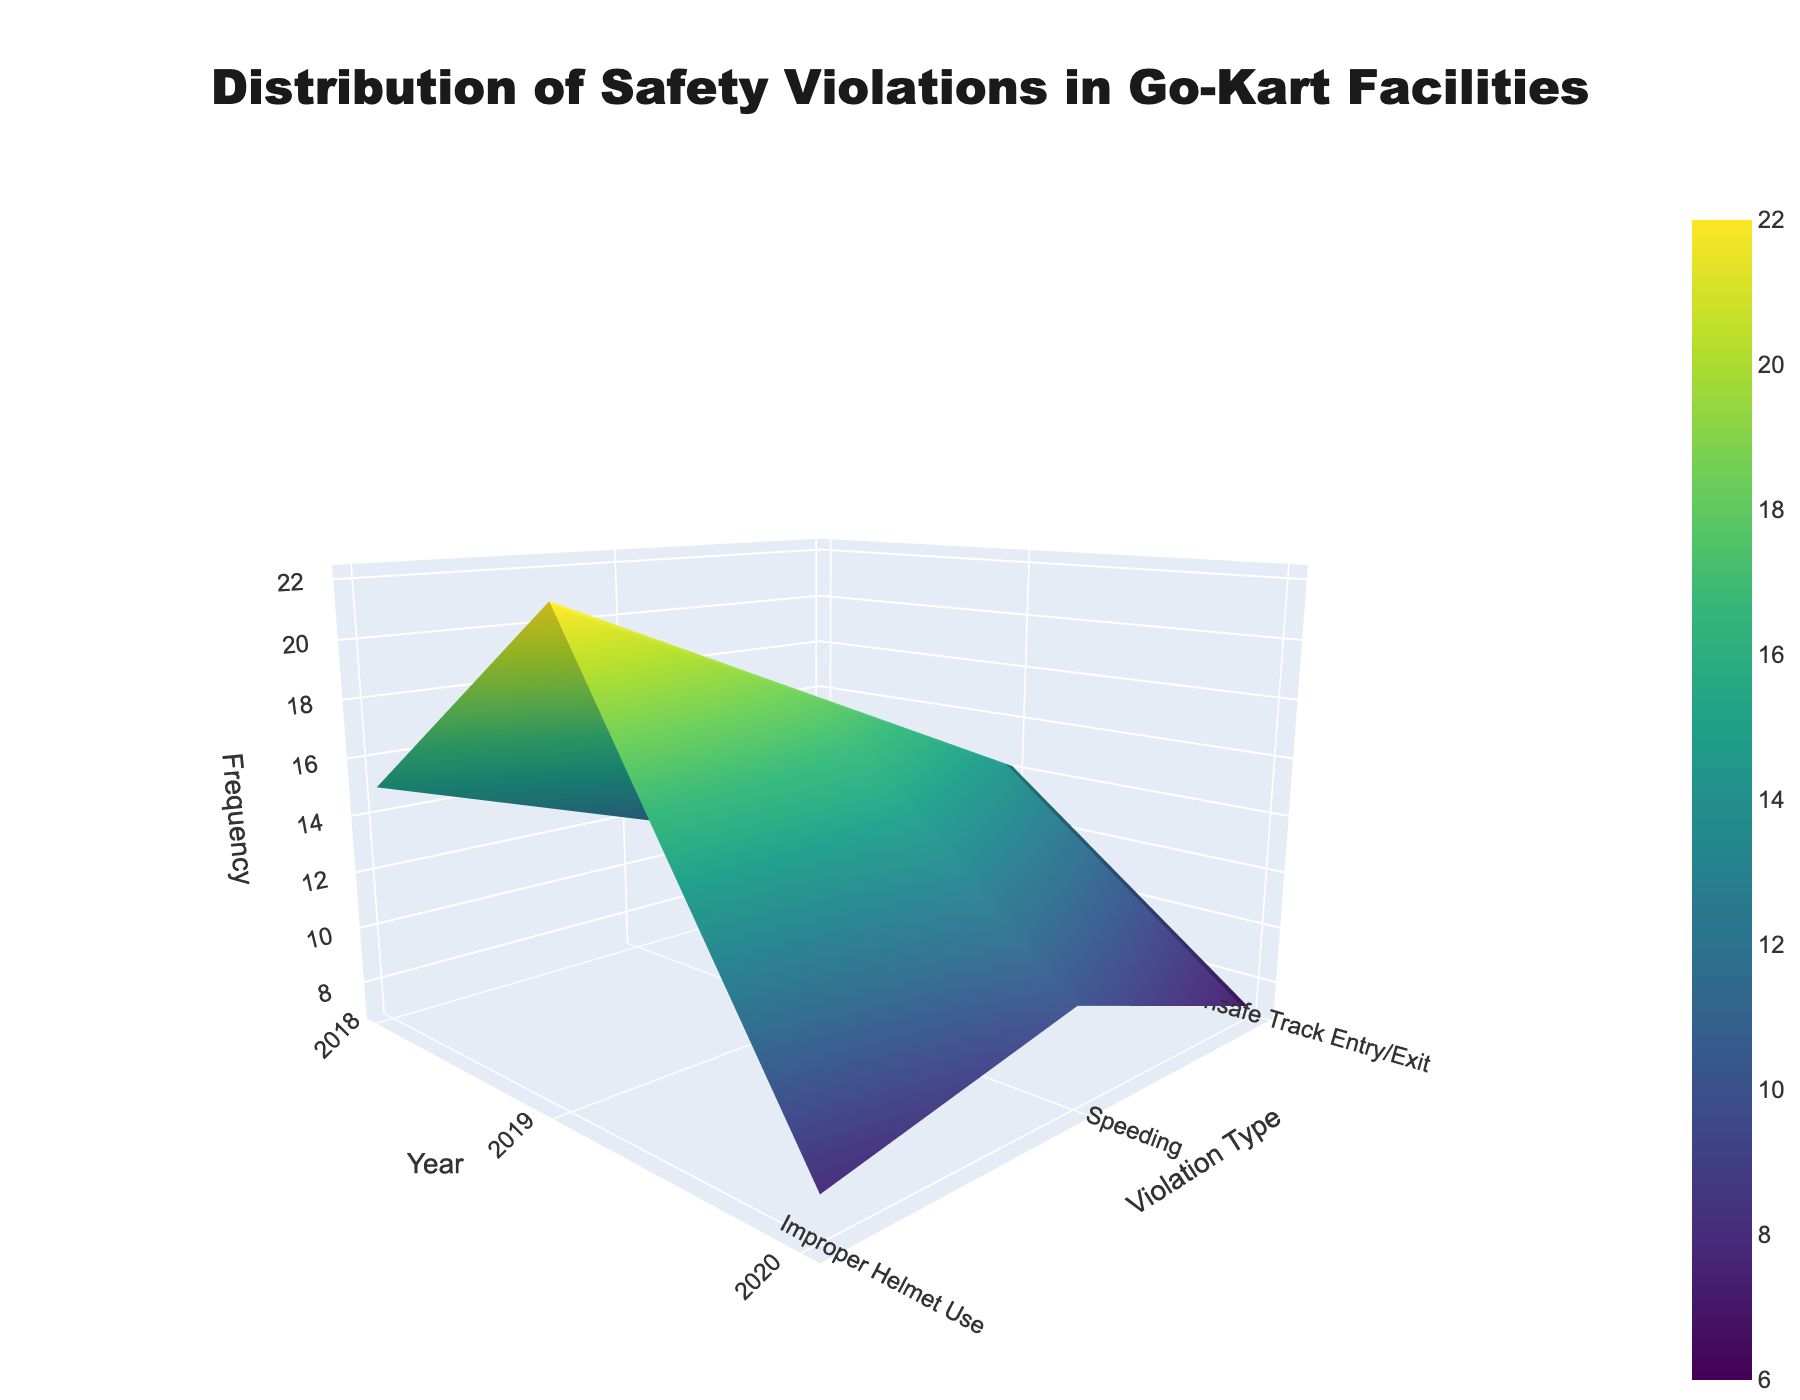What's the title of the plot? The title of a plot is usually located at the top center of the figure. In this case, you can see it in large, bold text at the top.
Answer: Distribution of Safety Violations in Go-Kart Facilities What are the axes labels? On a 3D surface plot, the axes labels are positioned next to each respective axis. Here, 'Year' corresponds to the horizontal axis, 'Violation Type' corresponds to the vertical axis, and 'Frequency' corresponds to the depth axis.
Answer: Year, Violation Type, Frequency Which year had the highest number of violations for 'Speeding'? Look for the highest point along the "Speeding" curve on the 'Year' axis. 2021 has the highest value for 'Speeding' at a noticeable peak.
Answer: 2021 Between which two years did 'Improper Helmet Use' violations decrease the most significantly? Find the 'Improper Helmet Use' on the 'Violation Type' axis, and identify the differences in heights along the 'Year' axis. The steepest drop is from 2018 to 2019.
Answer: 2018 to 2019 What is the total number of 'Unsafe Track Entry/Exit' violations from 2018 to 2022? Sum the values for 'Unsafe Track Entry/Exit' from each year: 2018 (8), 2019 (10), 2020 (7), 2021 (9), and 2022 (6). Thus, 8 + 10 + 7 + 9 + 6 = 40.
Answer: 40 Which violation type had the least overall frequency across all years? Locate the lowest average value across the 'Violation Type' axis. 'Unsafe Track Entry/Exit' consistently has lower values compared to the other types.
Answer: Unsafe Track Entry/Exit How does the frequency of 'Improper Helmet Use' compare to 'Speeding' in 2022? Compare the heights of the 2022 data points for 'Improper Helmet Use' and 'Speeding' on the plot. 'Speeding' (16) is higher than 'Improper Helmet Use' (8).
Answer: Speeding is higher What's the average frequency of 'Speeding' violations from 2018 to 2022? Sum the frequencies for 'Speeding' across all years and divide by the number of years: (22 + 18 + 14 + 20 + 16) / 5 = 90 / 5 = 18.
Answer: 18 Which year experienced the most balanced distribution across all violation types? Look at each year and find when the plot shows similar heights for all violation types. 2019 appears to have relatively balanced heights across the three violation types.
Answer: 2019 